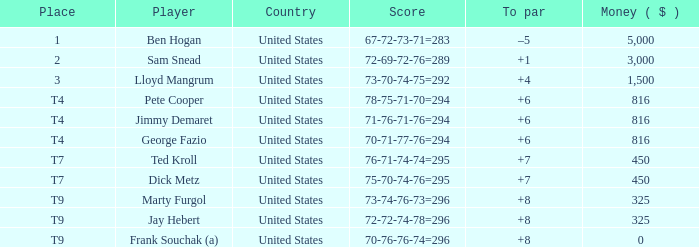What was Marty Furgol's place when he was paid less than $3,000? T9. 